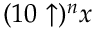<formula> <loc_0><loc_0><loc_500><loc_500>( 1 0 \uparrow ) ^ { n } x</formula> 